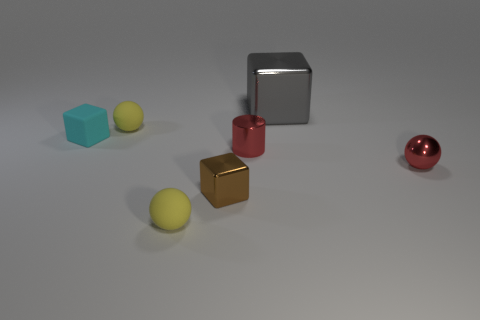Can you describe the size relationship between the objects? Certainly. The largest object is the gray metal cube, followed by the red cube that's smaller in size. The smallest objects are the spheres and a smaller cube, which appear to be around the same size. What can you tell me about the textures of these objects? The big metal cube exhibits a smooth, reflective surface, indicative of a metallic texture. The red and gold cubes and the red sphere display similar properties but slightly less reflective. The blue cube and the yellow spheres have matte surfaces, absorbing more light and lacking reflections. 